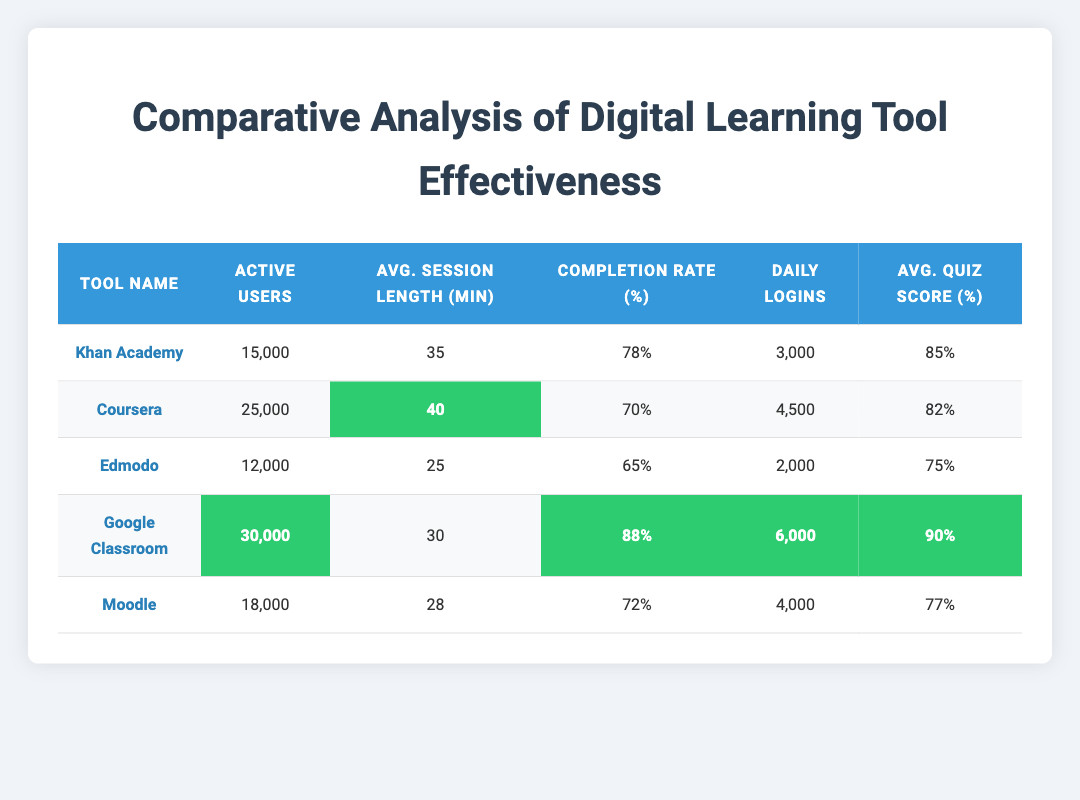What is the average session length for Google Classroom? According to the table, Google Classroom has an average session length of 30 minutes directly listed under that tool's metrics.
Answer: 30 Which digital learning tool has the highest quiz scores average percentage? By examining the quiz scores column, Google Classroom shows an average quiz score of 90%, which is higher than the other tools listed.
Answer: Google Classroom Is the completion rate for Coursera higher than that for Edmodo? In the table, Coursera has a completion rate of 70% and Edmodo has a completion rate of 65%. Since 70% is greater than 65%, the statement is true.
Answer: Yes How many more active users does Coursera have compared to Edmodo? The active users for Coursera are 25,000, while Edmodo has 12,000. The difference is calculated as 25,000 - 12,000 = 13,000.
Answer: 13,000 What is the average number of daily logins across all tools? To find the average daily logins, we first sum the daily logins: 3000 + 4500 + 2000 + 6000 + 4000 = 19500. Then, we divide by the number of tools, which is 5: 19500/5 = 3900.
Answer: 3900 Which tool had the least number of active users? By reviewing the active users column, Edmodo has the lowest value at 12,000 compared to the other tools listed.
Answer: Edmodo What percentage of tools has an average session length greater than 30 minutes? We analyze the session lengths: Khan Academy (35), Coursera (40), Google Classroom (30), Moodle (28), and Edmodo (25). The tools with more than 30 minutes are three. Since there are five tools, we calculate the percentage as (3/5) * 100 = 60%.
Answer: 60% Is there any tool that has both the highest daily logins and the highest completion rate? Google Classroom has 6,000 daily logins (the highest) and an 88% completion rate (the highest as well), which confirms both criteria are met for this tool.
Answer: Yes Which tool shows an average session length that is 5 minutes shorter than Moodle? Moodle's average session length is 28 minutes, thus 5 minutes shorter would be 23 minutes. Since Edmodo has an average of 25 minutes, it is the only tool that fits this criteria.
Answer: Edmodo 